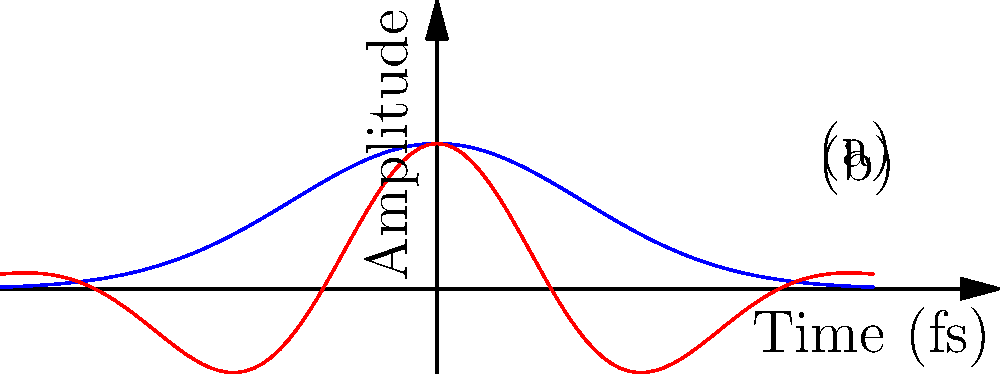The figure shows two ultrashort laser pulse envelopes: (a) a Gaussian envelope and (b) a chirped pulse. In the context of laser pulse propagation through dispersive media, explain how Group Velocity Dispersion (GVD) affects these pulses differently. Which pulse shape is more resistant to temporal broadening during propagation, and why? To understand how Group Velocity Dispersion (GVD) affects these pulses differently, let's break down the explanation into steps:

1. Gaussian Envelope (a):
   - The Gaussian envelope is described by the function $E(t) = E_0 e^{-t^2/2\tau^2}$, where $\tau$ is the pulse duration.
   - In the frequency domain, it has a Gaussian spectral distribution.

2. Chirped Pulse (b):
   - The chirped pulse has a time-dependent frequency, typically described as $E(t) = E_0 e^{-t^2/2\tau^2} \cos(\omega_0 t + bt^2)$, where $b$ is the chirp parameter.
   - It has a broader spectral width compared to the Gaussian pulse.

3. Group Velocity Dispersion (GVD):
   - GVD is characterized by the second-order dispersion coefficient $\beta_2 = \frac{d^2k}{d\omega^2}$.
   - It causes different frequency components of the pulse to travel at different velocities.

4. Effect on Gaussian Pulse:
   - GVD causes the Gaussian pulse to broaden temporally as it propagates.
   - The broadening is described by $\tau(z) = \tau_0 \sqrt{1 + (\frac{2\beta_2 z}{\tau_0^2})^2}$, where $z$ is the propagation distance.

5. Effect on Chirped Pulse:
   - The chirped pulse is pre-compensated for GVD.
   - Depending on the sign of the chirp, it can initially compress before broadening.
   - The chirp can partially counteract the GVD-induced broadening.

6. Resistance to Temporal Broadening:
   - The chirped pulse is more resistant to temporal broadening.
   - Its pre-existing frequency variation can be designed to counteract the GVD of the medium.
   - This allows for pulse compression or maintenance of pulse width over longer distances.

Therefore, the chirped pulse (b) is more resistant to temporal broadening during propagation through dispersive media due to its ability to counteract GVD effects.
Answer: Chirped pulse; pre-existing frequency variation counteracts GVD. 